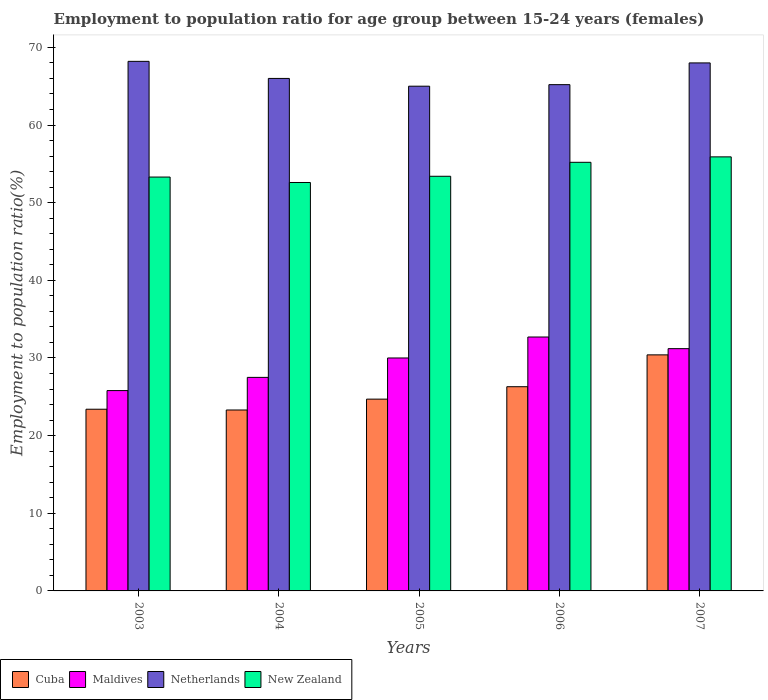How many groups of bars are there?
Ensure brevity in your answer.  5. Are the number of bars per tick equal to the number of legend labels?
Offer a terse response. Yes. How many bars are there on the 4th tick from the right?
Your response must be concise. 4. What is the label of the 2nd group of bars from the left?
Keep it short and to the point. 2004. Across all years, what is the maximum employment to population ratio in Cuba?
Offer a very short reply. 30.4. Across all years, what is the minimum employment to population ratio in Maldives?
Your answer should be compact. 25.8. What is the total employment to population ratio in New Zealand in the graph?
Give a very brief answer. 270.4. What is the difference between the employment to population ratio in Maldives in 2005 and that in 2007?
Give a very brief answer. -1.2. What is the difference between the employment to population ratio in Netherlands in 2005 and the employment to population ratio in Cuba in 2004?
Ensure brevity in your answer.  41.7. What is the average employment to population ratio in Netherlands per year?
Ensure brevity in your answer.  66.48. In the year 2006, what is the difference between the employment to population ratio in Maldives and employment to population ratio in Cuba?
Offer a very short reply. 6.4. What is the ratio of the employment to population ratio in Cuba in 2006 to that in 2007?
Provide a succinct answer. 0.87. Is the employment to population ratio in Maldives in 2004 less than that in 2006?
Your answer should be compact. Yes. Is the difference between the employment to population ratio in Maldives in 2003 and 2006 greater than the difference between the employment to population ratio in Cuba in 2003 and 2006?
Offer a very short reply. No. What is the difference between the highest and the second highest employment to population ratio in Cuba?
Offer a terse response. 4.1. What is the difference between the highest and the lowest employment to population ratio in Maldives?
Provide a short and direct response. 6.9. Is the sum of the employment to population ratio in Cuba in 2004 and 2005 greater than the maximum employment to population ratio in Netherlands across all years?
Provide a succinct answer. No. What does the 2nd bar from the left in 2006 represents?
Your answer should be compact. Maldives. Is it the case that in every year, the sum of the employment to population ratio in Cuba and employment to population ratio in Maldives is greater than the employment to population ratio in New Zealand?
Provide a short and direct response. No. Are all the bars in the graph horizontal?
Your answer should be very brief. No. Does the graph contain any zero values?
Give a very brief answer. No. Does the graph contain grids?
Your answer should be compact. No. How are the legend labels stacked?
Your response must be concise. Horizontal. What is the title of the graph?
Provide a short and direct response. Employment to population ratio for age group between 15-24 years (females). What is the label or title of the Y-axis?
Your answer should be very brief. Employment to population ratio(%). What is the Employment to population ratio(%) of Cuba in 2003?
Keep it short and to the point. 23.4. What is the Employment to population ratio(%) of Maldives in 2003?
Provide a short and direct response. 25.8. What is the Employment to population ratio(%) in Netherlands in 2003?
Keep it short and to the point. 68.2. What is the Employment to population ratio(%) in New Zealand in 2003?
Your answer should be very brief. 53.3. What is the Employment to population ratio(%) in Cuba in 2004?
Offer a very short reply. 23.3. What is the Employment to population ratio(%) of Maldives in 2004?
Your answer should be very brief. 27.5. What is the Employment to population ratio(%) of Netherlands in 2004?
Offer a very short reply. 66. What is the Employment to population ratio(%) of New Zealand in 2004?
Offer a very short reply. 52.6. What is the Employment to population ratio(%) of Cuba in 2005?
Give a very brief answer. 24.7. What is the Employment to population ratio(%) in Netherlands in 2005?
Give a very brief answer. 65. What is the Employment to population ratio(%) in New Zealand in 2005?
Ensure brevity in your answer.  53.4. What is the Employment to population ratio(%) in Cuba in 2006?
Offer a very short reply. 26.3. What is the Employment to population ratio(%) of Maldives in 2006?
Give a very brief answer. 32.7. What is the Employment to population ratio(%) of Netherlands in 2006?
Give a very brief answer. 65.2. What is the Employment to population ratio(%) of New Zealand in 2006?
Your answer should be very brief. 55.2. What is the Employment to population ratio(%) in Cuba in 2007?
Provide a short and direct response. 30.4. What is the Employment to population ratio(%) in Maldives in 2007?
Give a very brief answer. 31.2. What is the Employment to population ratio(%) in New Zealand in 2007?
Give a very brief answer. 55.9. Across all years, what is the maximum Employment to population ratio(%) of Cuba?
Make the answer very short. 30.4. Across all years, what is the maximum Employment to population ratio(%) of Maldives?
Ensure brevity in your answer.  32.7. Across all years, what is the maximum Employment to population ratio(%) in Netherlands?
Your answer should be very brief. 68.2. Across all years, what is the maximum Employment to population ratio(%) in New Zealand?
Make the answer very short. 55.9. Across all years, what is the minimum Employment to population ratio(%) of Cuba?
Your answer should be compact. 23.3. Across all years, what is the minimum Employment to population ratio(%) in Maldives?
Make the answer very short. 25.8. Across all years, what is the minimum Employment to population ratio(%) of Netherlands?
Give a very brief answer. 65. Across all years, what is the minimum Employment to population ratio(%) of New Zealand?
Offer a terse response. 52.6. What is the total Employment to population ratio(%) in Cuba in the graph?
Provide a succinct answer. 128.1. What is the total Employment to population ratio(%) of Maldives in the graph?
Your response must be concise. 147.2. What is the total Employment to population ratio(%) in Netherlands in the graph?
Provide a short and direct response. 332.4. What is the total Employment to population ratio(%) in New Zealand in the graph?
Keep it short and to the point. 270.4. What is the difference between the Employment to population ratio(%) of Netherlands in 2003 and that in 2004?
Offer a terse response. 2.2. What is the difference between the Employment to population ratio(%) in New Zealand in 2003 and that in 2004?
Your answer should be compact. 0.7. What is the difference between the Employment to population ratio(%) of New Zealand in 2003 and that in 2005?
Make the answer very short. -0.1. What is the difference between the Employment to population ratio(%) in Netherlands in 2003 and that in 2006?
Provide a succinct answer. 3. What is the difference between the Employment to population ratio(%) in New Zealand in 2003 and that in 2006?
Ensure brevity in your answer.  -1.9. What is the difference between the Employment to population ratio(%) in Cuba in 2003 and that in 2007?
Your answer should be compact. -7. What is the difference between the Employment to population ratio(%) of Netherlands in 2003 and that in 2007?
Give a very brief answer. 0.2. What is the difference between the Employment to population ratio(%) of Maldives in 2004 and that in 2005?
Provide a succinct answer. -2.5. What is the difference between the Employment to population ratio(%) of Netherlands in 2004 and that in 2005?
Your response must be concise. 1. What is the difference between the Employment to population ratio(%) of New Zealand in 2004 and that in 2005?
Make the answer very short. -0.8. What is the difference between the Employment to population ratio(%) of Netherlands in 2004 and that in 2006?
Provide a succinct answer. 0.8. What is the difference between the Employment to population ratio(%) of New Zealand in 2004 and that in 2006?
Your response must be concise. -2.6. What is the difference between the Employment to population ratio(%) of New Zealand in 2004 and that in 2007?
Make the answer very short. -3.3. What is the difference between the Employment to population ratio(%) in Cuba in 2005 and that in 2006?
Your answer should be compact. -1.6. What is the difference between the Employment to population ratio(%) in Maldives in 2005 and that in 2006?
Give a very brief answer. -2.7. What is the difference between the Employment to population ratio(%) in New Zealand in 2005 and that in 2006?
Provide a short and direct response. -1.8. What is the difference between the Employment to population ratio(%) in Cuba in 2005 and that in 2007?
Ensure brevity in your answer.  -5.7. What is the difference between the Employment to population ratio(%) in Maldives in 2005 and that in 2007?
Keep it short and to the point. -1.2. What is the difference between the Employment to population ratio(%) of New Zealand in 2005 and that in 2007?
Provide a short and direct response. -2.5. What is the difference between the Employment to population ratio(%) in Maldives in 2006 and that in 2007?
Make the answer very short. 1.5. What is the difference between the Employment to population ratio(%) of Netherlands in 2006 and that in 2007?
Offer a terse response. -2.8. What is the difference between the Employment to population ratio(%) of Cuba in 2003 and the Employment to population ratio(%) of Maldives in 2004?
Your answer should be very brief. -4.1. What is the difference between the Employment to population ratio(%) in Cuba in 2003 and the Employment to population ratio(%) in Netherlands in 2004?
Offer a very short reply. -42.6. What is the difference between the Employment to population ratio(%) in Cuba in 2003 and the Employment to population ratio(%) in New Zealand in 2004?
Your response must be concise. -29.2. What is the difference between the Employment to population ratio(%) of Maldives in 2003 and the Employment to population ratio(%) of Netherlands in 2004?
Your answer should be very brief. -40.2. What is the difference between the Employment to population ratio(%) of Maldives in 2003 and the Employment to population ratio(%) of New Zealand in 2004?
Keep it short and to the point. -26.8. What is the difference between the Employment to population ratio(%) in Netherlands in 2003 and the Employment to population ratio(%) in New Zealand in 2004?
Your answer should be very brief. 15.6. What is the difference between the Employment to population ratio(%) in Cuba in 2003 and the Employment to population ratio(%) in Maldives in 2005?
Provide a succinct answer. -6.6. What is the difference between the Employment to population ratio(%) of Cuba in 2003 and the Employment to population ratio(%) of Netherlands in 2005?
Provide a succinct answer. -41.6. What is the difference between the Employment to population ratio(%) of Cuba in 2003 and the Employment to population ratio(%) of New Zealand in 2005?
Keep it short and to the point. -30. What is the difference between the Employment to population ratio(%) in Maldives in 2003 and the Employment to population ratio(%) in Netherlands in 2005?
Offer a terse response. -39.2. What is the difference between the Employment to population ratio(%) of Maldives in 2003 and the Employment to population ratio(%) of New Zealand in 2005?
Offer a terse response. -27.6. What is the difference between the Employment to population ratio(%) in Cuba in 2003 and the Employment to population ratio(%) in Netherlands in 2006?
Your answer should be very brief. -41.8. What is the difference between the Employment to population ratio(%) in Cuba in 2003 and the Employment to population ratio(%) in New Zealand in 2006?
Give a very brief answer. -31.8. What is the difference between the Employment to population ratio(%) in Maldives in 2003 and the Employment to population ratio(%) in Netherlands in 2006?
Offer a terse response. -39.4. What is the difference between the Employment to population ratio(%) of Maldives in 2003 and the Employment to population ratio(%) of New Zealand in 2006?
Your response must be concise. -29.4. What is the difference between the Employment to population ratio(%) of Netherlands in 2003 and the Employment to population ratio(%) of New Zealand in 2006?
Ensure brevity in your answer.  13. What is the difference between the Employment to population ratio(%) in Cuba in 2003 and the Employment to population ratio(%) in Maldives in 2007?
Offer a terse response. -7.8. What is the difference between the Employment to population ratio(%) in Cuba in 2003 and the Employment to population ratio(%) in Netherlands in 2007?
Give a very brief answer. -44.6. What is the difference between the Employment to population ratio(%) in Cuba in 2003 and the Employment to population ratio(%) in New Zealand in 2007?
Your answer should be compact. -32.5. What is the difference between the Employment to population ratio(%) in Maldives in 2003 and the Employment to population ratio(%) in Netherlands in 2007?
Provide a short and direct response. -42.2. What is the difference between the Employment to population ratio(%) of Maldives in 2003 and the Employment to population ratio(%) of New Zealand in 2007?
Provide a succinct answer. -30.1. What is the difference between the Employment to population ratio(%) in Netherlands in 2003 and the Employment to population ratio(%) in New Zealand in 2007?
Your answer should be compact. 12.3. What is the difference between the Employment to population ratio(%) of Cuba in 2004 and the Employment to population ratio(%) of Netherlands in 2005?
Your answer should be compact. -41.7. What is the difference between the Employment to population ratio(%) of Cuba in 2004 and the Employment to population ratio(%) of New Zealand in 2005?
Your response must be concise. -30.1. What is the difference between the Employment to population ratio(%) of Maldives in 2004 and the Employment to population ratio(%) of Netherlands in 2005?
Give a very brief answer. -37.5. What is the difference between the Employment to population ratio(%) in Maldives in 2004 and the Employment to population ratio(%) in New Zealand in 2005?
Your answer should be very brief. -25.9. What is the difference between the Employment to population ratio(%) in Netherlands in 2004 and the Employment to population ratio(%) in New Zealand in 2005?
Offer a very short reply. 12.6. What is the difference between the Employment to population ratio(%) of Cuba in 2004 and the Employment to population ratio(%) of Netherlands in 2006?
Give a very brief answer. -41.9. What is the difference between the Employment to population ratio(%) in Cuba in 2004 and the Employment to population ratio(%) in New Zealand in 2006?
Your answer should be compact. -31.9. What is the difference between the Employment to population ratio(%) of Maldives in 2004 and the Employment to population ratio(%) of Netherlands in 2006?
Give a very brief answer. -37.7. What is the difference between the Employment to population ratio(%) of Maldives in 2004 and the Employment to population ratio(%) of New Zealand in 2006?
Give a very brief answer. -27.7. What is the difference between the Employment to population ratio(%) in Netherlands in 2004 and the Employment to population ratio(%) in New Zealand in 2006?
Your answer should be compact. 10.8. What is the difference between the Employment to population ratio(%) of Cuba in 2004 and the Employment to population ratio(%) of Netherlands in 2007?
Give a very brief answer. -44.7. What is the difference between the Employment to population ratio(%) in Cuba in 2004 and the Employment to population ratio(%) in New Zealand in 2007?
Ensure brevity in your answer.  -32.6. What is the difference between the Employment to population ratio(%) of Maldives in 2004 and the Employment to population ratio(%) of Netherlands in 2007?
Make the answer very short. -40.5. What is the difference between the Employment to population ratio(%) in Maldives in 2004 and the Employment to population ratio(%) in New Zealand in 2007?
Make the answer very short. -28.4. What is the difference between the Employment to population ratio(%) of Netherlands in 2004 and the Employment to population ratio(%) of New Zealand in 2007?
Your response must be concise. 10.1. What is the difference between the Employment to population ratio(%) in Cuba in 2005 and the Employment to population ratio(%) in Netherlands in 2006?
Provide a short and direct response. -40.5. What is the difference between the Employment to population ratio(%) of Cuba in 2005 and the Employment to population ratio(%) of New Zealand in 2006?
Your answer should be very brief. -30.5. What is the difference between the Employment to population ratio(%) of Maldives in 2005 and the Employment to population ratio(%) of Netherlands in 2006?
Give a very brief answer. -35.2. What is the difference between the Employment to population ratio(%) in Maldives in 2005 and the Employment to population ratio(%) in New Zealand in 2006?
Your answer should be very brief. -25.2. What is the difference between the Employment to population ratio(%) in Cuba in 2005 and the Employment to population ratio(%) in Maldives in 2007?
Ensure brevity in your answer.  -6.5. What is the difference between the Employment to population ratio(%) in Cuba in 2005 and the Employment to population ratio(%) in Netherlands in 2007?
Your answer should be compact. -43.3. What is the difference between the Employment to population ratio(%) of Cuba in 2005 and the Employment to population ratio(%) of New Zealand in 2007?
Your answer should be compact. -31.2. What is the difference between the Employment to population ratio(%) of Maldives in 2005 and the Employment to population ratio(%) of Netherlands in 2007?
Offer a terse response. -38. What is the difference between the Employment to population ratio(%) of Maldives in 2005 and the Employment to population ratio(%) of New Zealand in 2007?
Offer a very short reply. -25.9. What is the difference between the Employment to population ratio(%) in Netherlands in 2005 and the Employment to population ratio(%) in New Zealand in 2007?
Your answer should be compact. 9.1. What is the difference between the Employment to population ratio(%) of Cuba in 2006 and the Employment to population ratio(%) of Netherlands in 2007?
Give a very brief answer. -41.7. What is the difference between the Employment to population ratio(%) of Cuba in 2006 and the Employment to population ratio(%) of New Zealand in 2007?
Provide a short and direct response. -29.6. What is the difference between the Employment to population ratio(%) in Maldives in 2006 and the Employment to population ratio(%) in Netherlands in 2007?
Provide a short and direct response. -35.3. What is the difference between the Employment to population ratio(%) in Maldives in 2006 and the Employment to population ratio(%) in New Zealand in 2007?
Your answer should be compact. -23.2. What is the difference between the Employment to population ratio(%) in Netherlands in 2006 and the Employment to population ratio(%) in New Zealand in 2007?
Your response must be concise. 9.3. What is the average Employment to population ratio(%) in Cuba per year?
Offer a very short reply. 25.62. What is the average Employment to population ratio(%) in Maldives per year?
Give a very brief answer. 29.44. What is the average Employment to population ratio(%) in Netherlands per year?
Offer a very short reply. 66.48. What is the average Employment to population ratio(%) of New Zealand per year?
Provide a succinct answer. 54.08. In the year 2003, what is the difference between the Employment to population ratio(%) in Cuba and Employment to population ratio(%) in Netherlands?
Offer a terse response. -44.8. In the year 2003, what is the difference between the Employment to population ratio(%) in Cuba and Employment to population ratio(%) in New Zealand?
Keep it short and to the point. -29.9. In the year 2003, what is the difference between the Employment to population ratio(%) in Maldives and Employment to population ratio(%) in Netherlands?
Offer a terse response. -42.4. In the year 2003, what is the difference between the Employment to population ratio(%) of Maldives and Employment to population ratio(%) of New Zealand?
Make the answer very short. -27.5. In the year 2004, what is the difference between the Employment to population ratio(%) in Cuba and Employment to population ratio(%) in Netherlands?
Provide a short and direct response. -42.7. In the year 2004, what is the difference between the Employment to population ratio(%) of Cuba and Employment to population ratio(%) of New Zealand?
Your answer should be very brief. -29.3. In the year 2004, what is the difference between the Employment to population ratio(%) in Maldives and Employment to population ratio(%) in Netherlands?
Offer a very short reply. -38.5. In the year 2004, what is the difference between the Employment to population ratio(%) of Maldives and Employment to population ratio(%) of New Zealand?
Provide a succinct answer. -25.1. In the year 2004, what is the difference between the Employment to population ratio(%) of Netherlands and Employment to population ratio(%) of New Zealand?
Provide a short and direct response. 13.4. In the year 2005, what is the difference between the Employment to population ratio(%) in Cuba and Employment to population ratio(%) in Maldives?
Keep it short and to the point. -5.3. In the year 2005, what is the difference between the Employment to population ratio(%) in Cuba and Employment to population ratio(%) in Netherlands?
Give a very brief answer. -40.3. In the year 2005, what is the difference between the Employment to population ratio(%) of Cuba and Employment to population ratio(%) of New Zealand?
Your answer should be very brief. -28.7. In the year 2005, what is the difference between the Employment to population ratio(%) in Maldives and Employment to population ratio(%) in Netherlands?
Ensure brevity in your answer.  -35. In the year 2005, what is the difference between the Employment to population ratio(%) of Maldives and Employment to population ratio(%) of New Zealand?
Ensure brevity in your answer.  -23.4. In the year 2006, what is the difference between the Employment to population ratio(%) of Cuba and Employment to population ratio(%) of Netherlands?
Provide a succinct answer. -38.9. In the year 2006, what is the difference between the Employment to population ratio(%) in Cuba and Employment to population ratio(%) in New Zealand?
Offer a terse response. -28.9. In the year 2006, what is the difference between the Employment to population ratio(%) of Maldives and Employment to population ratio(%) of Netherlands?
Your response must be concise. -32.5. In the year 2006, what is the difference between the Employment to population ratio(%) of Maldives and Employment to population ratio(%) of New Zealand?
Offer a terse response. -22.5. In the year 2006, what is the difference between the Employment to population ratio(%) in Netherlands and Employment to population ratio(%) in New Zealand?
Give a very brief answer. 10. In the year 2007, what is the difference between the Employment to population ratio(%) of Cuba and Employment to population ratio(%) of Maldives?
Give a very brief answer. -0.8. In the year 2007, what is the difference between the Employment to population ratio(%) of Cuba and Employment to population ratio(%) of Netherlands?
Make the answer very short. -37.6. In the year 2007, what is the difference between the Employment to population ratio(%) in Cuba and Employment to population ratio(%) in New Zealand?
Keep it short and to the point. -25.5. In the year 2007, what is the difference between the Employment to population ratio(%) of Maldives and Employment to population ratio(%) of Netherlands?
Offer a terse response. -36.8. In the year 2007, what is the difference between the Employment to population ratio(%) of Maldives and Employment to population ratio(%) of New Zealand?
Your response must be concise. -24.7. In the year 2007, what is the difference between the Employment to population ratio(%) in Netherlands and Employment to population ratio(%) in New Zealand?
Ensure brevity in your answer.  12.1. What is the ratio of the Employment to population ratio(%) in Maldives in 2003 to that in 2004?
Your answer should be very brief. 0.94. What is the ratio of the Employment to population ratio(%) of Netherlands in 2003 to that in 2004?
Offer a terse response. 1.03. What is the ratio of the Employment to population ratio(%) of New Zealand in 2003 to that in 2004?
Give a very brief answer. 1.01. What is the ratio of the Employment to population ratio(%) of Cuba in 2003 to that in 2005?
Make the answer very short. 0.95. What is the ratio of the Employment to population ratio(%) in Maldives in 2003 to that in 2005?
Offer a very short reply. 0.86. What is the ratio of the Employment to population ratio(%) in Netherlands in 2003 to that in 2005?
Offer a terse response. 1.05. What is the ratio of the Employment to population ratio(%) of New Zealand in 2003 to that in 2005?
Give a very brief answer. 1. What is the ratio of the Employment to population ratio(%) of Cuba in 2003 to that in 2006?
Make the answer very short. 0.89. What is the ratio of the Employment to population ratio(%) of Maldives in 2003 to that in 2006?
Give a very brief answer. 0.79. What is the ratio of the Employment to population ratio(%) of Netherlands in 2003 to that in 2006?
Give a very brief answer. 1.05. What is the ratio of the Employment to population ratio(%) of New Zealand in 2003 to that in 2006?
Ensure brevity in your answer.  0.97. What is the ratio of the Employment to population ratio(%) of Cuba in 2003 to that in 2007?
Ensure brevity in your answer.  0.77. What is the ratio of the Employment to population ratio(%) of Maldives in 2003 to that in 2007?
Ensure brevity in your answer.  0.83. What is the ratio of the Employment to population ratio(%) of Netherlands in 2003 to that in 2007?
Keep it short and to the point. 1. What is the ratio of the Employment to population ratio(%) in New Zealand in 2003 to that in 2007?
Offer a terse response. 0.95. What is the ratio of the Employment to population ratio(%) of Cuba in 2004 to that in 2005?
Keep it short and to the point. 0.94. What is the ratio of the Employment to population ratio(%) in Netherlands in 2004 to that in 2005?
Ensure brevity in your answer.  1.02. What is the ratio of the Employment to population ratio(%) of Cuba in 2004 to that in 2006?
Your response must be concise. 0.89. What is the ratio of the Employment to population ratio(%) in Maldives in 2004 to that in 2006?
Ensure brevity in your answer.  0.84. What is the ratio of the Employment to population ratio(%) in Netherlands in 2004 to that in 2006?
Ensure brevity in your answer.  1.01. What is the ratio of the Employment to population ratio(%) of New Zealand in 2004 to that in 2006?
Make the answer very short. 0.95. What is the ratio of the Employment to population ratio(%) in Cuba in 2004 to that in 2007?
Give a very brief answer. 0.77. What is the ratio of the Employment to population ratio(%) of Maldives in 2004 to that in 2007?
Your answer should be compact. 0.88. What is the ratio of the Employment to population ratio(%) in Netherlands in 2004 to that in 2007?
Provide a succinct answer. 0.97. What is the ratio of the Employment to population ratio(%) in New Zealand in 2004 to that in 2007?
Ensure brevity in your answer.  0.94. What is the ratio of the Employment to population ratio(%) in Cuba in 2005 to that in 2006?
Provide a succinct answer. 0.94. What is the ratio of the Employment to population ratio(%) of Maldives in 2005 to that in 2006?
Ensure brevity in your answer.  0.92. What is the ratio of the Employment to population ratio(%) of New Zealand in 2005 to that in 2006?
Ensure brevity in your answer.  0.97. What is the ratio of the Employment to population ratio(%) of Cuba in 2005 to that in 2007?
Your answer should be compact. 0.81. What is the ratio of the Employment to population ratio(%) of Maldives in 2005 to that in 2007?
Your answer should be very brief. 0.96. What is the ratio of the Employment to population ratio(%) of Netherlands in 2005 to that in 2007?
Your answer should be very brief. 0.96. What is the ratio of the Employment to population ratio(%) of New Zealand in 2005 to that in 2007?
Ensure brevity in your answer.  0.96. What is the ratio of the Employment to population ratio(%) in Cuba in 2006 to that in 2007?
Your answer should be very brief. 0.87. What is the ratio of the Employment to population ratio(%) in Maldives in 2006 to that in 2007?
Your response must be concise. 1.05. What is the ratio of the Employment to population ratio(%) in Netherlands in 2006 to that in 2007?
Offer a very short reply. 0.96. What is the ratio of the Employment to population ratio(%) in New Zealand in 2006 to that in 2007?
Your answer should be very brief. 0.99. What is the difference between the highest and the lowest Employment to population ratio(%) in Cuba?
Your answer should be compact. 7.1. What is the difference between the highest and the lowest Employment to population ratio(%) in Maldives?
Your answer should be very brief. 6.9. What is the difference between the highest and the lowest Employment to population ratio(%) in New Zealand?
Keep it short and to the point. 3.3. 